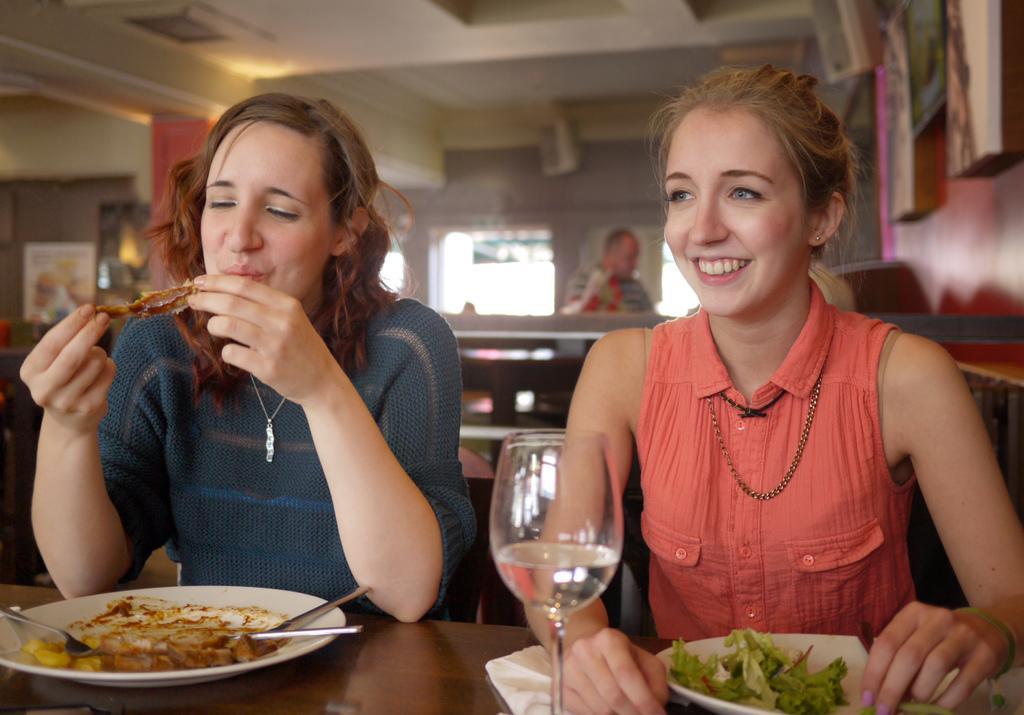Can you describe this image briefly? In this picture we can see two women are sitting in front of a table, there are plates, a tissue paper and a glass of drink placed on the table, we can see some food in these plates, in the background there are some boards and another person, we can see a blurry background, we can also see a fork and spoons on this plate. 